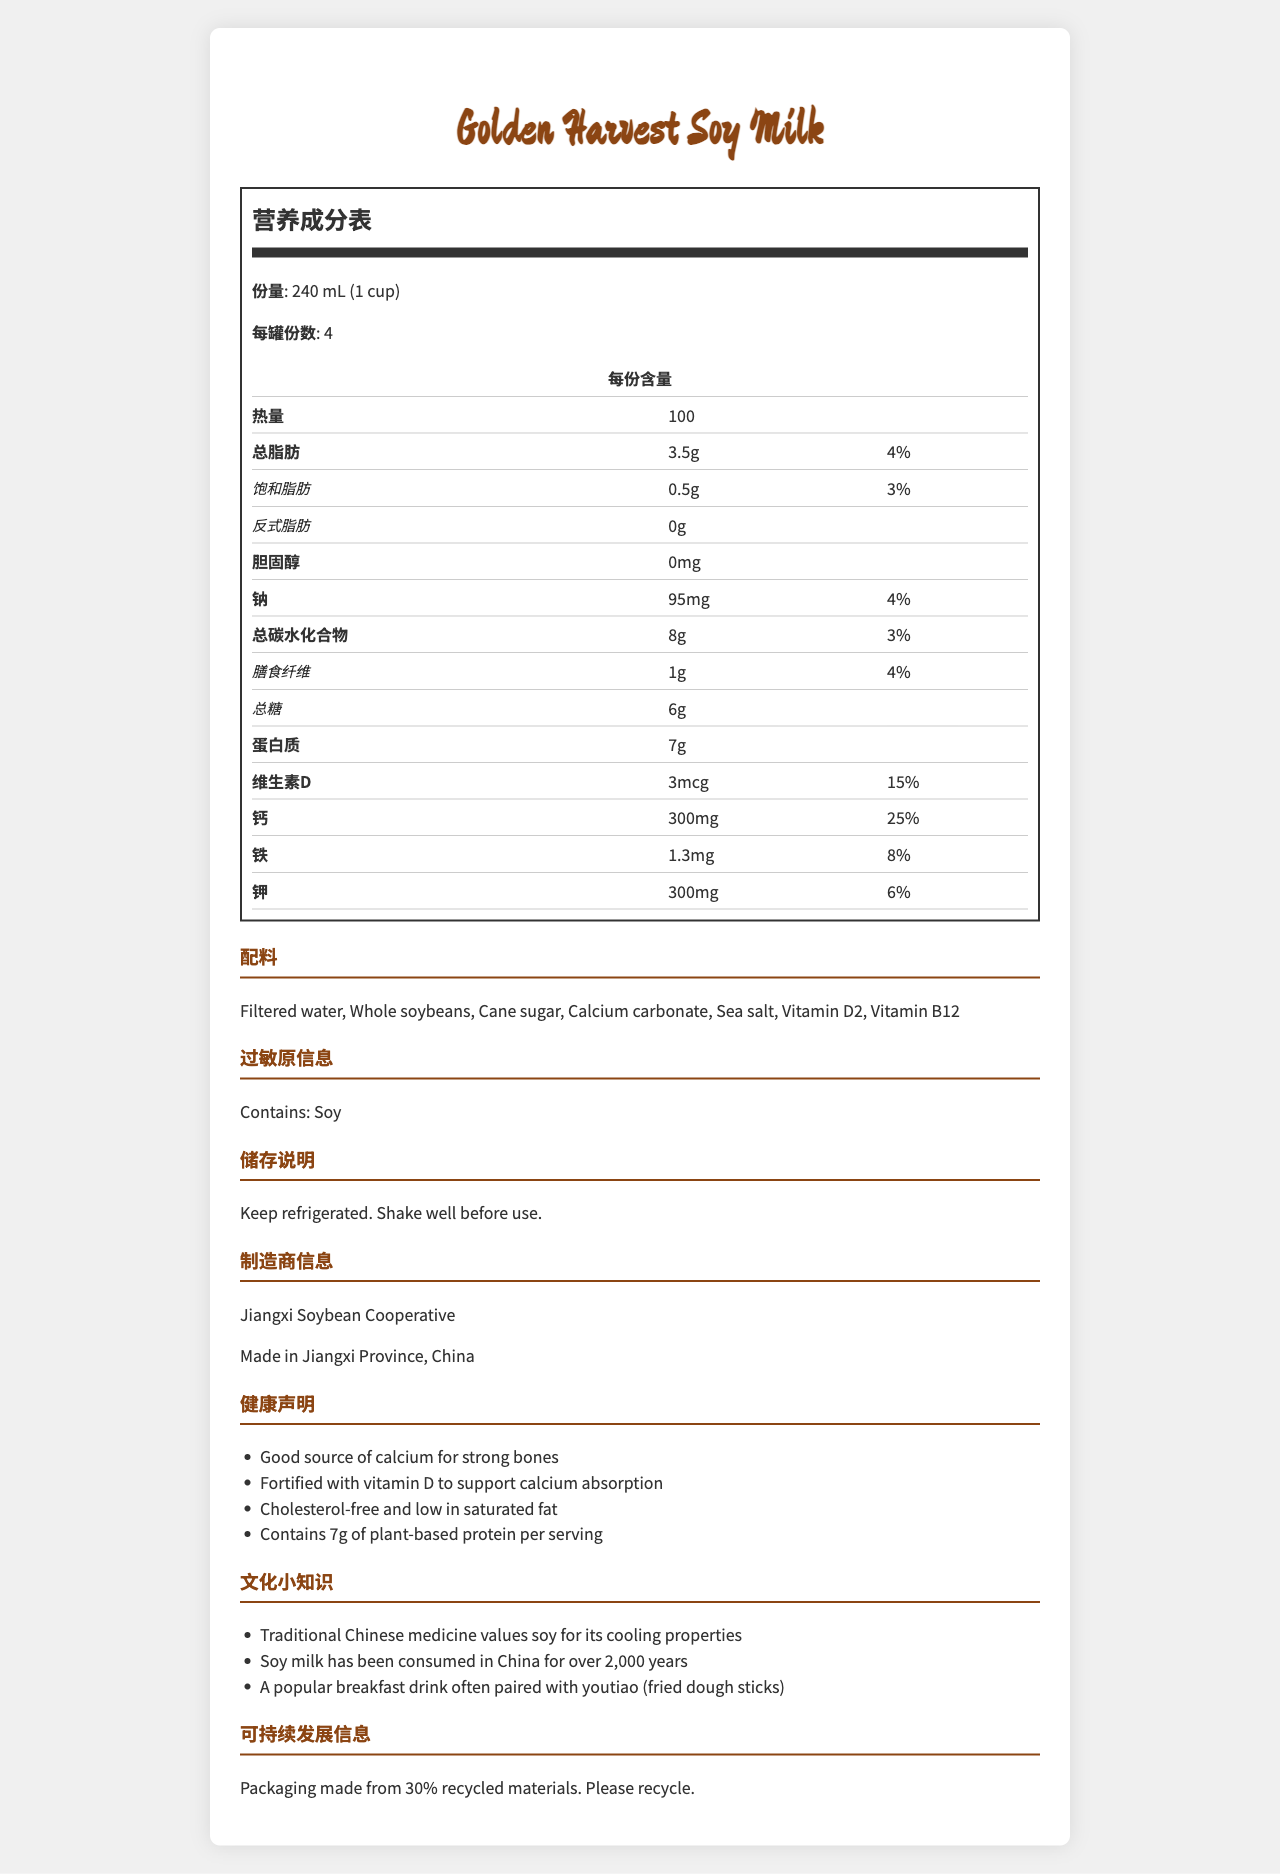which product is the Nutrition Facts Label for? The manufacturer is Golden Harvest, and it is stated at the top of the document.
Answer: Golden Harvest Soy Milk what is the serving size for this soy milk? In the document, the serving size is mentioned as 240 mL which is equivalent to 1 cup.
Answer: 240 mL (1 cup) how many servings are there per container? The document clearly states that there are 4 servings per container.
Answer: 4 what is the calorie count per serving? The document lists the calorie count per serving right under the nutritional breakdown.
Answer: 100 calories what percentage of daily value is provided by the calcium in this soy milk? The document specifies that calcium provides 25% of the daily value per serving.
Answer: 25% what is the main role of vitamin D mentioned in the document? The health claims section states that vitamin D is fortified to support calcium absorption.
Answer: To support calcium absorption what is the main ingredient in the soy milk? A. Cane sugar B. Whole soybeans C. Filtered water D. Calcium carbonate The ingredients list starts with filtered water, indicating it is the main ingredient.
Answer: C. Filtered water which vitamin has the highest daily value percentage in this soy milk? A. Vitamin D B. Calcium C. Iron D. Potassium The daily value for calcium is 25%, which is the highest among the vitamins and minerals listed.
Answer: B. Calcium is there any cholesterol in this soy milk? The document specifically lists cholesterol content as 0mg.
Answer: No does this soy milk contain any iron? The document shows that there is 1.3mg of iron, which constitutes 8% of the daily value.
Answer: Yes can this soy milk support bone health? Why or why not? The health claims mention that it is a good source of calcium for strong bones and fortified with vitamin D to support calcium absorption.
Answer: Yes, because it is a good source of calcium and vitamin D has soy milk been consumed in China historically? The cultural notes mention that soy milk has been consumed in China for over 2,000 years.
Answer: Yes is the packaging of this soy milk environmentally friendly? The document states that the packaging is made from 30% recycled materials and asks consumers to recycle it.
Answer: Yes who makes this soy milk? The manufacturer info on the document lists Jiangxi Soybean Cooperative as the producer of this soy milk.
Answer: Jiangxi Soybean Cooperative do the cultural notes mention that soy is valued for cooling properties in traditional Chinese medicine? One of the cultural notes states that traditional Chinese medicine values soy for its cooling properties.
Answer: Yes does this soy milk contain any nuts? The document only lists soy as an allergen, and there is no information about whether it contains other nuts.
Answer: Cannot be determined is this soy milk required to be refrigerated? A. Yes B. No C. Sometimes D. Not stated The storage instructions clearly state that the product should be kept refrigerated.
Answer: A. Yes what is the main idea of this document? The entire document is centered around informing consumers about the nutritional benefits and cultural aspects of Golden Harvest Soy Milk, including its ingredients, and health-related attributes.
Answer: The document provides detailed nutritional information, ingredients, allergen details, health claims, cultural notes, and sustainability information about Golden Harvest Soy Milk. 